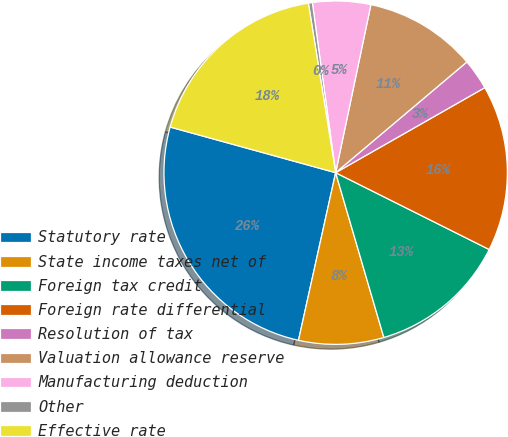Convert chart. <chart><loc_0><loc_0><loc_500><loc_500><pie_chart><fcel>Statutory rate<fcel>State income taxes net of<fcel>Foreign tax credit<fcel>Foreign rate differential<fcel>Resolution of tax<fcel>Valuation allowance reserve<fcel>Manufacturing deduction<fcel>Other<fcel>Effective rate<nl><fcel>25.81%<fcel>8.0%<fcel>13.09%<fcel>15.63%<fcel>2.91%<fcel>10.55%<fcel>5.46%<fcel>0.37%<fcel>18.18%<nl></chart> 